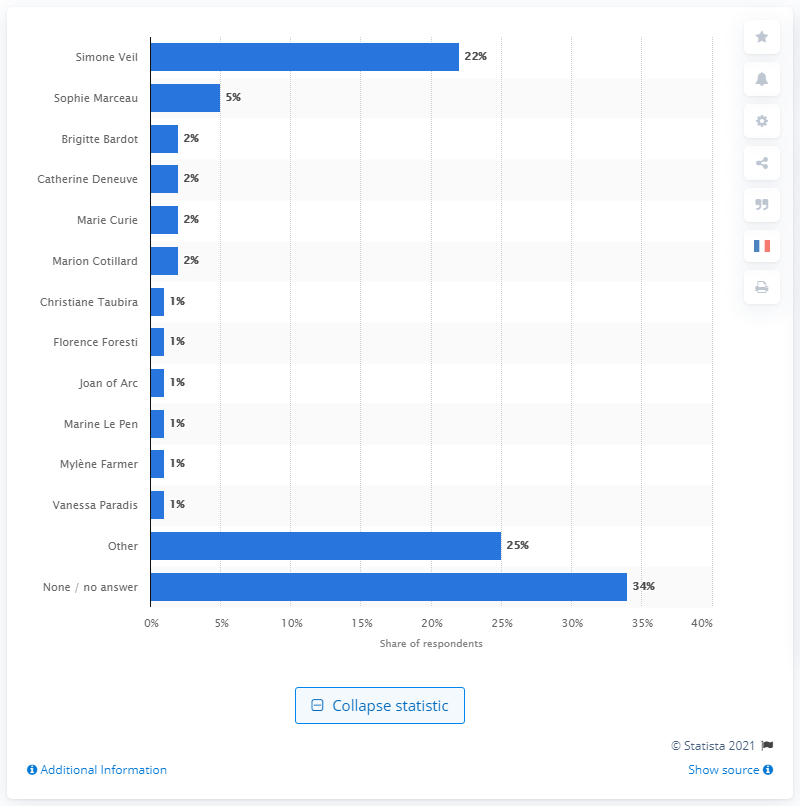Identify some key points in this picture. Simone Veil, a former politician who served as Minister of Health, is known for her contributions to public health policy in France. 